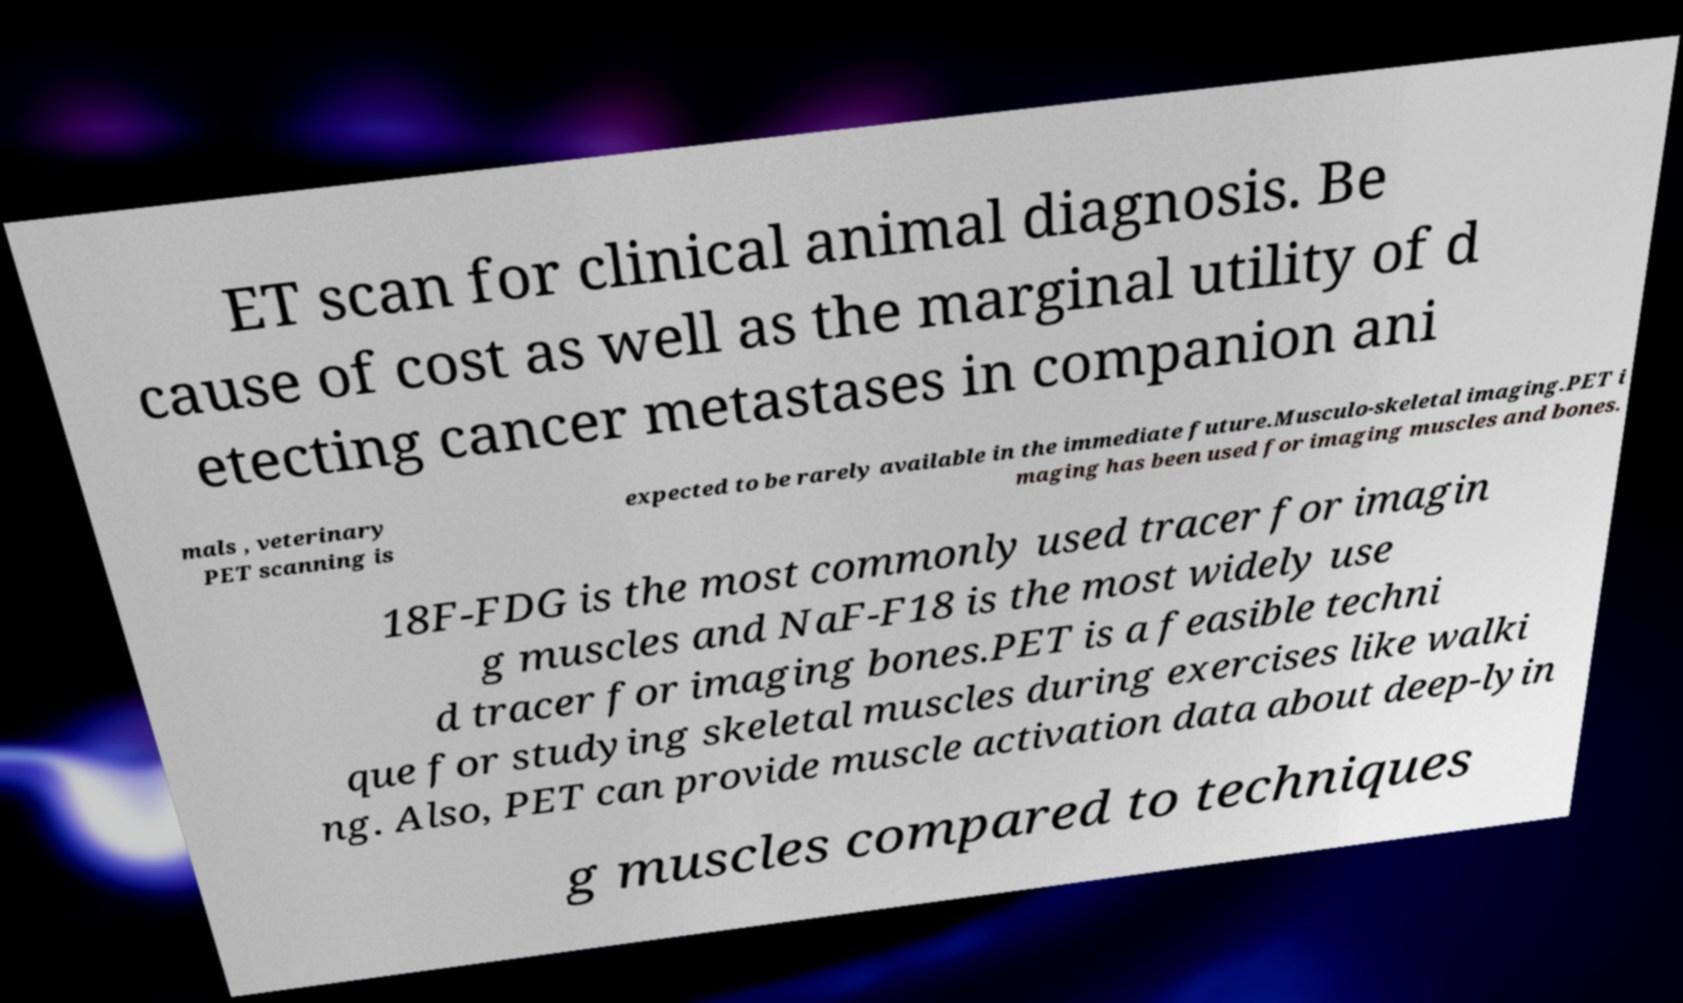Please read and relay the text visible in this image. What does it say? ET scan for clinical animal diagnosis. Be cause of cost as well as the marginal utility of d etecting cancer metastases in companion ani mals , veterinary PET scanning is expected to be rarely available in the immediate future.Musculo-skeletal imaging.PET i maging has been used for imaging muscles and bones. 18F-FDG is the most commonly used tracer for imagin g muscles and NaF-F18 is the most widely use d tracer for imaging bones.PET is a feasible techni que for studying skeletal muscles during exercises like walki ng. Also, PET can provide muscle activation data about deep-lyin g muscles compared to techniques 